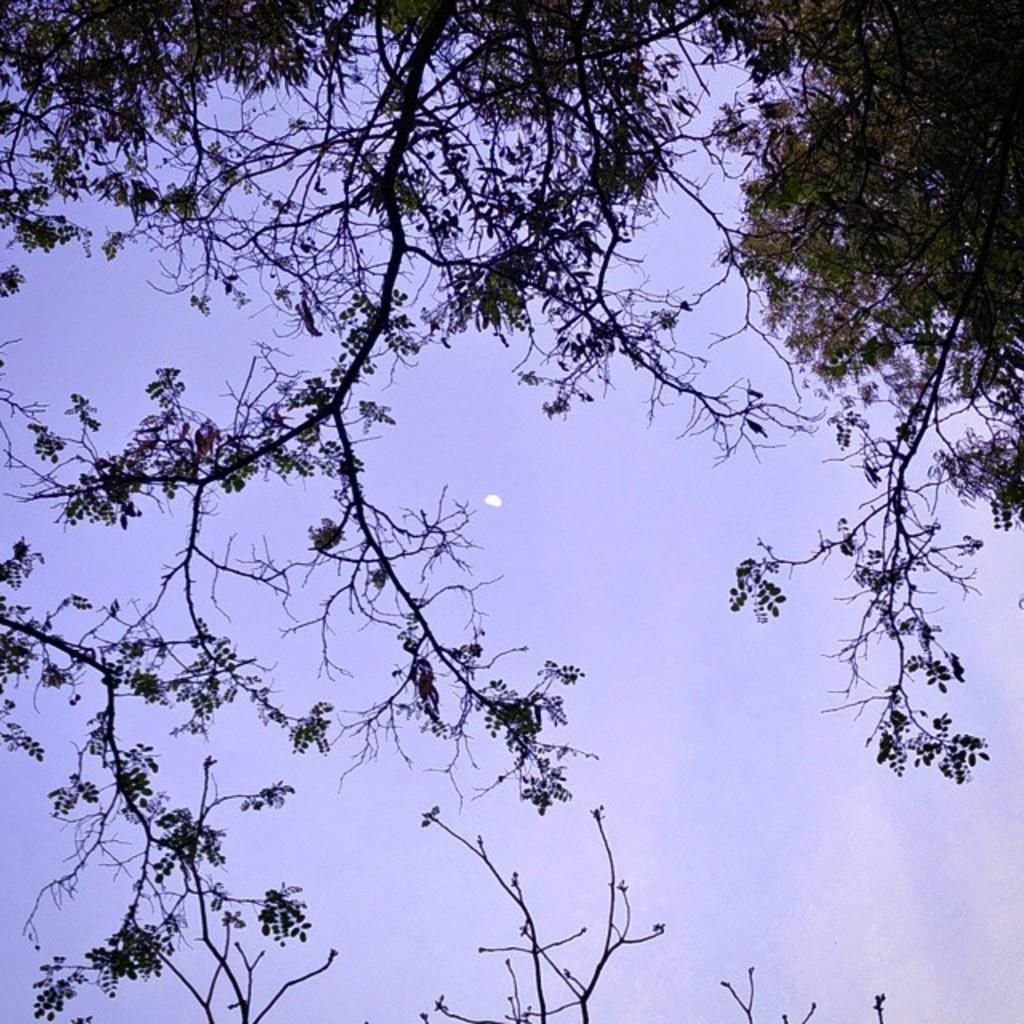What natural element is present in the image? There is a part of a tree in the image. What can be seen in the background of the image? The sky is visible in the image. What celestial body is visible in the sky? The moon is visible in the sky. What type of fruit is hanging from the tree in the image? There is no fruit visible in the image; only a part of the tree is present. 